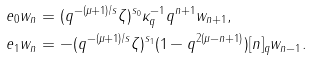<formula> <loc_0><loc_0><loc_500><loc_500>& e _ { 0 } w _ { n } = ( q ^ { - ( \mu + 1 ) / s } \zeta ) ^ { s _ { 0 } } \kappa _ { q } ^ { - 1 } q ^ { n + 1 } w _ { n + 1 } , \\ & e _ { 1 } w _ { n } = - ( q ^ { - ( \mu + 1 ) / s } \zeta ) ^ { s _ { 1 } } ( 1 - q ^ { 2 ( \mu - n + 1 ) } ) [ n ] _ { q } w _ { n - 1 } .</formula> 